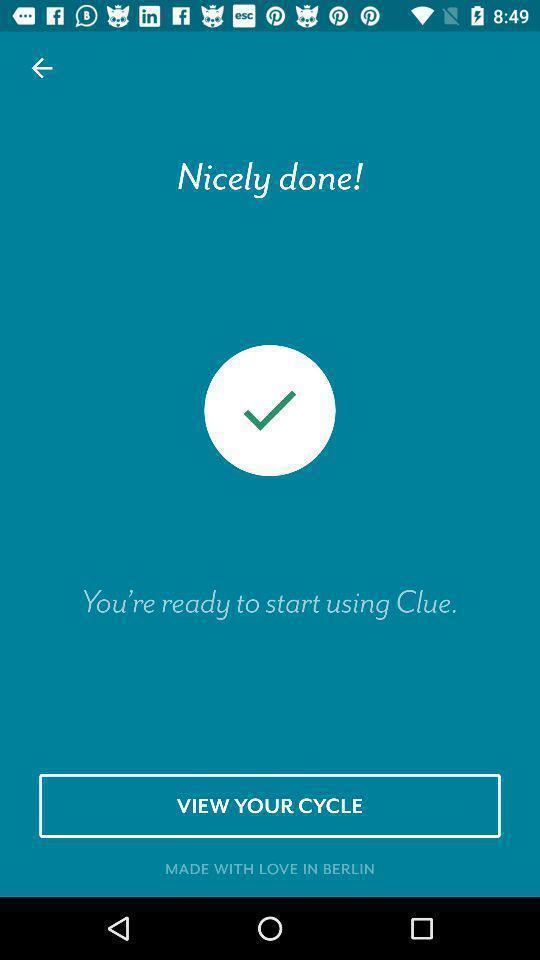Summarize the main components in this picture. Welcome page. 